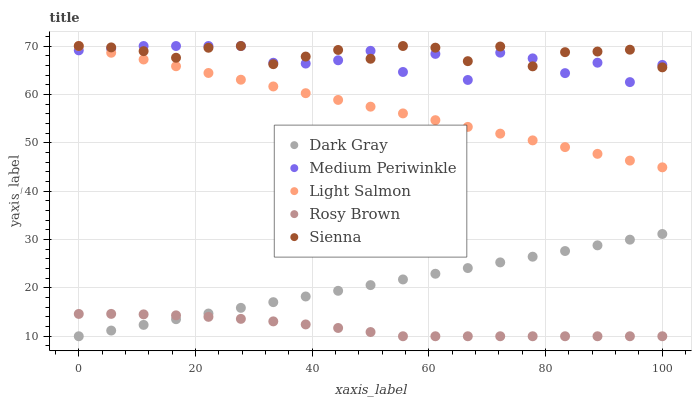Does Rosy Brown have the minimum area under the curve?
Answer yes or no. Yes. Does Sienna have the maximum area under the curve?
Answer yes or no. Yes. Does Light Salmon have the minimum area under the curve?
Answer yes or no. No. Does Light Salmon have the maximum area under the curve?
Answer yes or no. No. Is Dark Gray the smoothest?
Answer yes or no. Yes. Is Medium Periwinkle the roughest?
Answer yes or no. Yes. Is Sienna the smoothest?
Answer yes or no. No. Is Sienna the roughest?
Answer yes or no. No. Does Dark Gray have the lowest value?
Answer yes or no. Yes. Does Light Salmon have the lowest value?
Answer yes or no. No. Does Medium Periwinkle have the highest value?
Answer yes or no. Yes. Does Rosy Brown have the highest value?
Answer yes or no. No. Is Rosy Brown less than Light Salmon?
Answer yes or no. Yes. Is Sienna greater than Rosy Brown?
Answer yes or no. Yes. Does Medium Periwinkle intersect Sienna?
Answer yes or no. Yes. Is Medium Periwinkle less than Sienna?
Answer yes or no. No. Is Medium Periwinkle greater than Sienna?
Answer yes or no. No. Does Rosy Brown intersect Light Salmon?
Answer yes or no. No. 